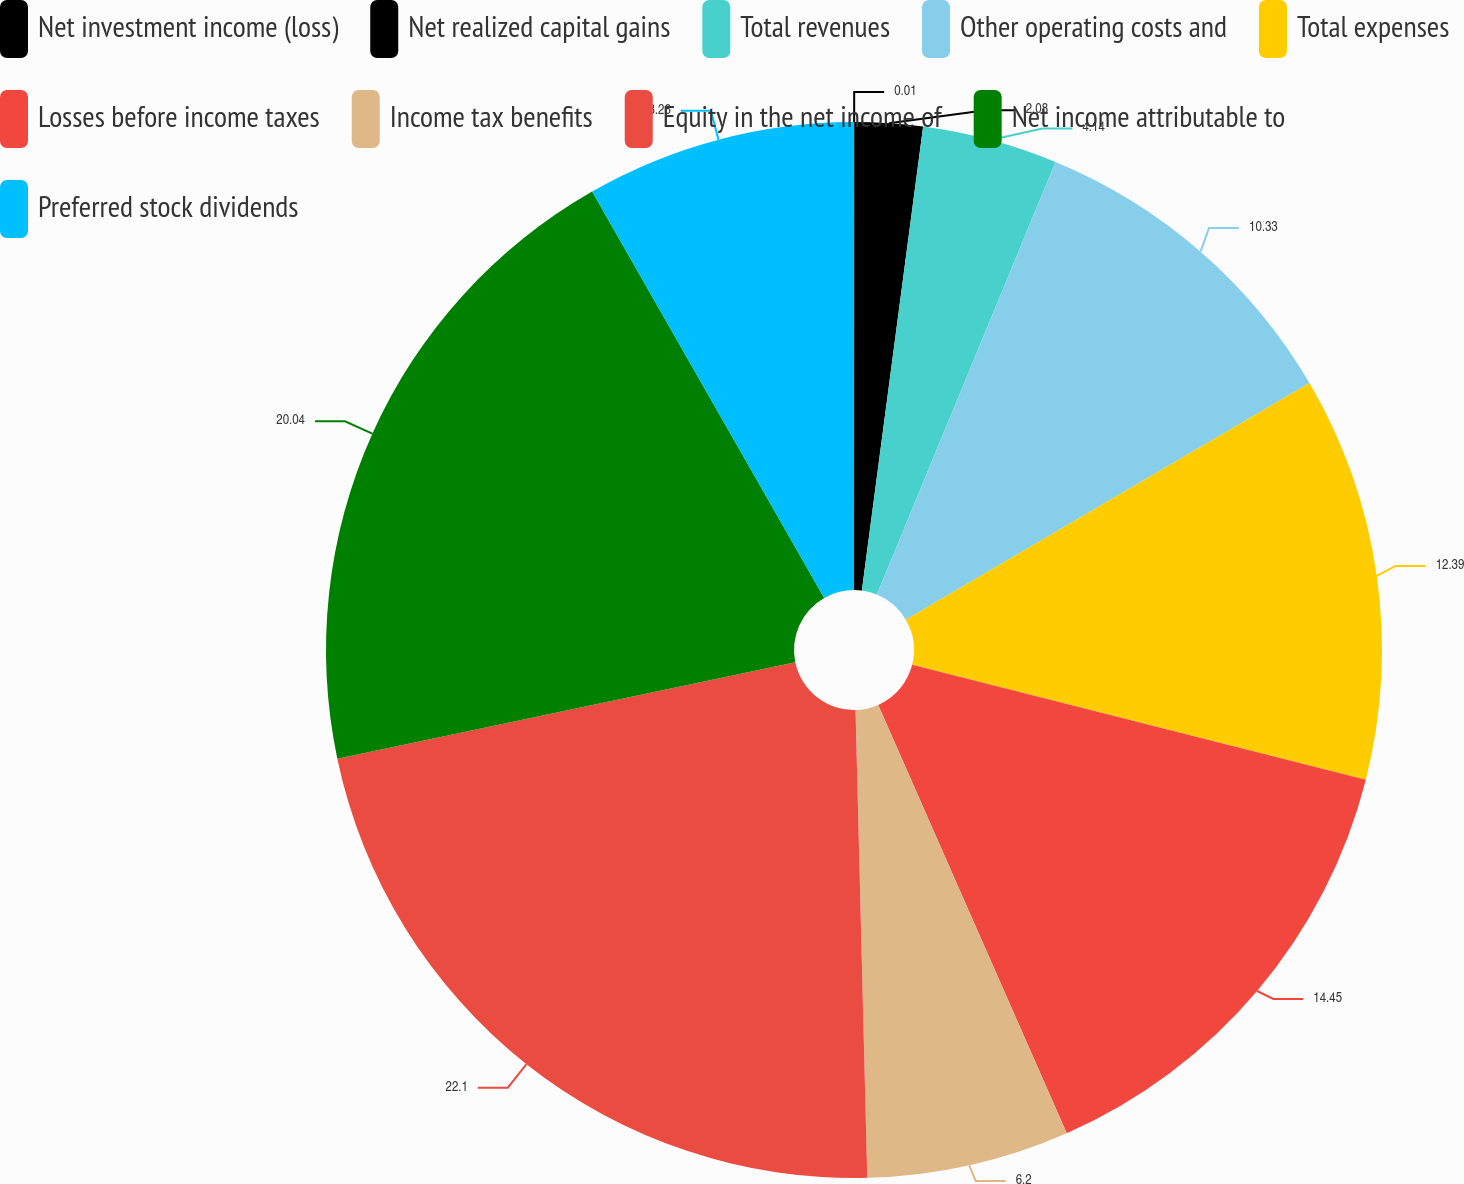Convert chart to OTSL. <chart><loc_0><loc_0><loc_500><loc_500><pie_chart><fcel>Net investment income (loss)<fcel>Net realized capital gains<fcel>Total revenues<fcel>Other operating costs and<fcel>Total expenses<fcel>Losses before income taxes<fcel>Income tax benefits<fcel>Equity in the net income of<fcel>Net income attributable to<fcel>Preferred stock dividends<nl><fcel>0.01%<fcel>2.08%<fcel>4.14%<fcel>10.33%<fcel>12.39%<fcel>14.45%<fcel>6.2%<fcel>22.1%<fcel>20.04%<fcel>8.26%<nl></chart> 